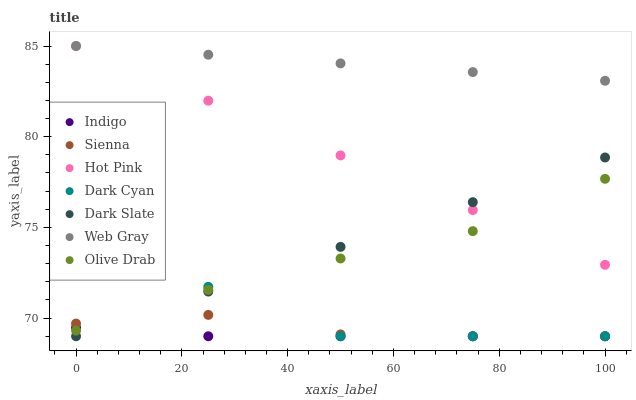Does Indigo have the minimum area under the curve?
Answer yes or no. Yes. Does Web Gray have the maximum area under the curve?
Answer yes or no. Yes. Does Hot Pink have the minimum area under the curve?
Answer yes or no. No. Does Hot Pink have the maximum area under the curve?
Answer yes or no. No. Is Hot Pink the smoothest?
Answer yes or no. Yes. Is Dark Cyan the roughest?
Answer yes or no. Yes. Is Indigo the smoothest?
Answer yes or no. No. Is Indigo the roughest?
Answer yes or no. No. Does Indigo have the lowest value?
Answer yes or no. Yes. Does Hot Pink have the lowest value?
Answer yes or no. No. Does Hot Pink have the highest value?
Answer yes or no. Yes. Does Indigo have the highest value?
Answer yes or no. No. Is Dark Cyan less than Hot Pink?
Answer yes or no. Yes. Is Web Gray greater than Dark Cyan?
Answer yes or no. Yes. Does Sienna intersect Dark Cyan?
Answer yes or no. Yes. Is Sienna less than Dark Cyan?
Answer yes or no. No. Is Sienna greater than Dark Cyan?
Answer yes or no. No. Does Dark Cyan intersect Hot Pink?
Answer yes or no. No. 